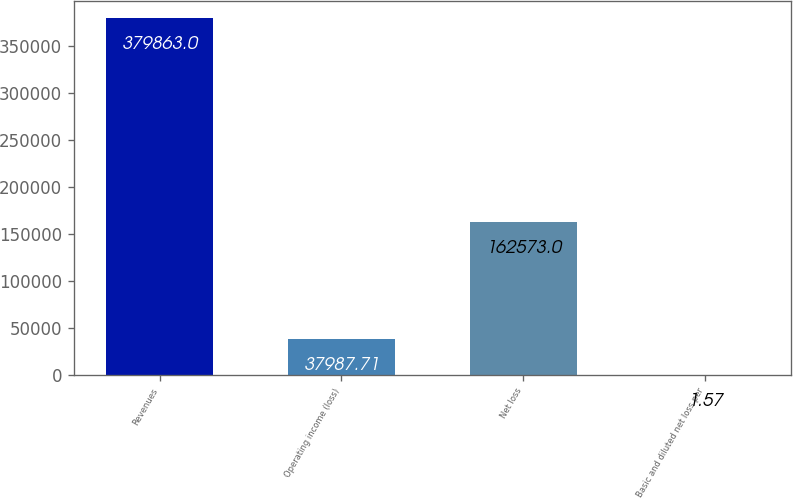<chart> <loc_0><loc_0><loc_500><loc_500><bar_chart><fcel>Revenues<fcel>Operating income (loss)<fcel>Net loss<fcel>Basic and diluted net loss per<nl><fcel>379863<fcel>37987.7<fcel>162573<fcel>1.57<nl></chart> 